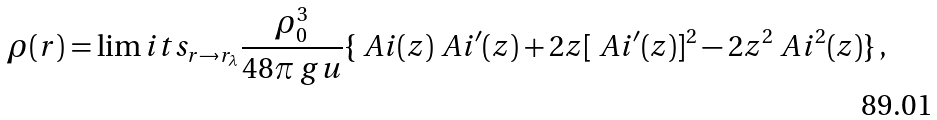Convert formula to latex. <formula><loc_0><loc_0><loc_500><loc_500>\rho ( r ) = \lim i t s _ { r \rightarrow r _ { \lambda } } \frac { \rho _ { 0 } ^ { 3 } } { 4 8 \pi \ g u } \{ \ A i ( z ) \ A i ^ { \prime } ( z ) + 2 z [ \ A i ^ { \prime } ( z ) ] ^ { 2 } - 2 z ^ { 2 } \ A i ^ { 2 } ( z ) \} \, ,</formula> 